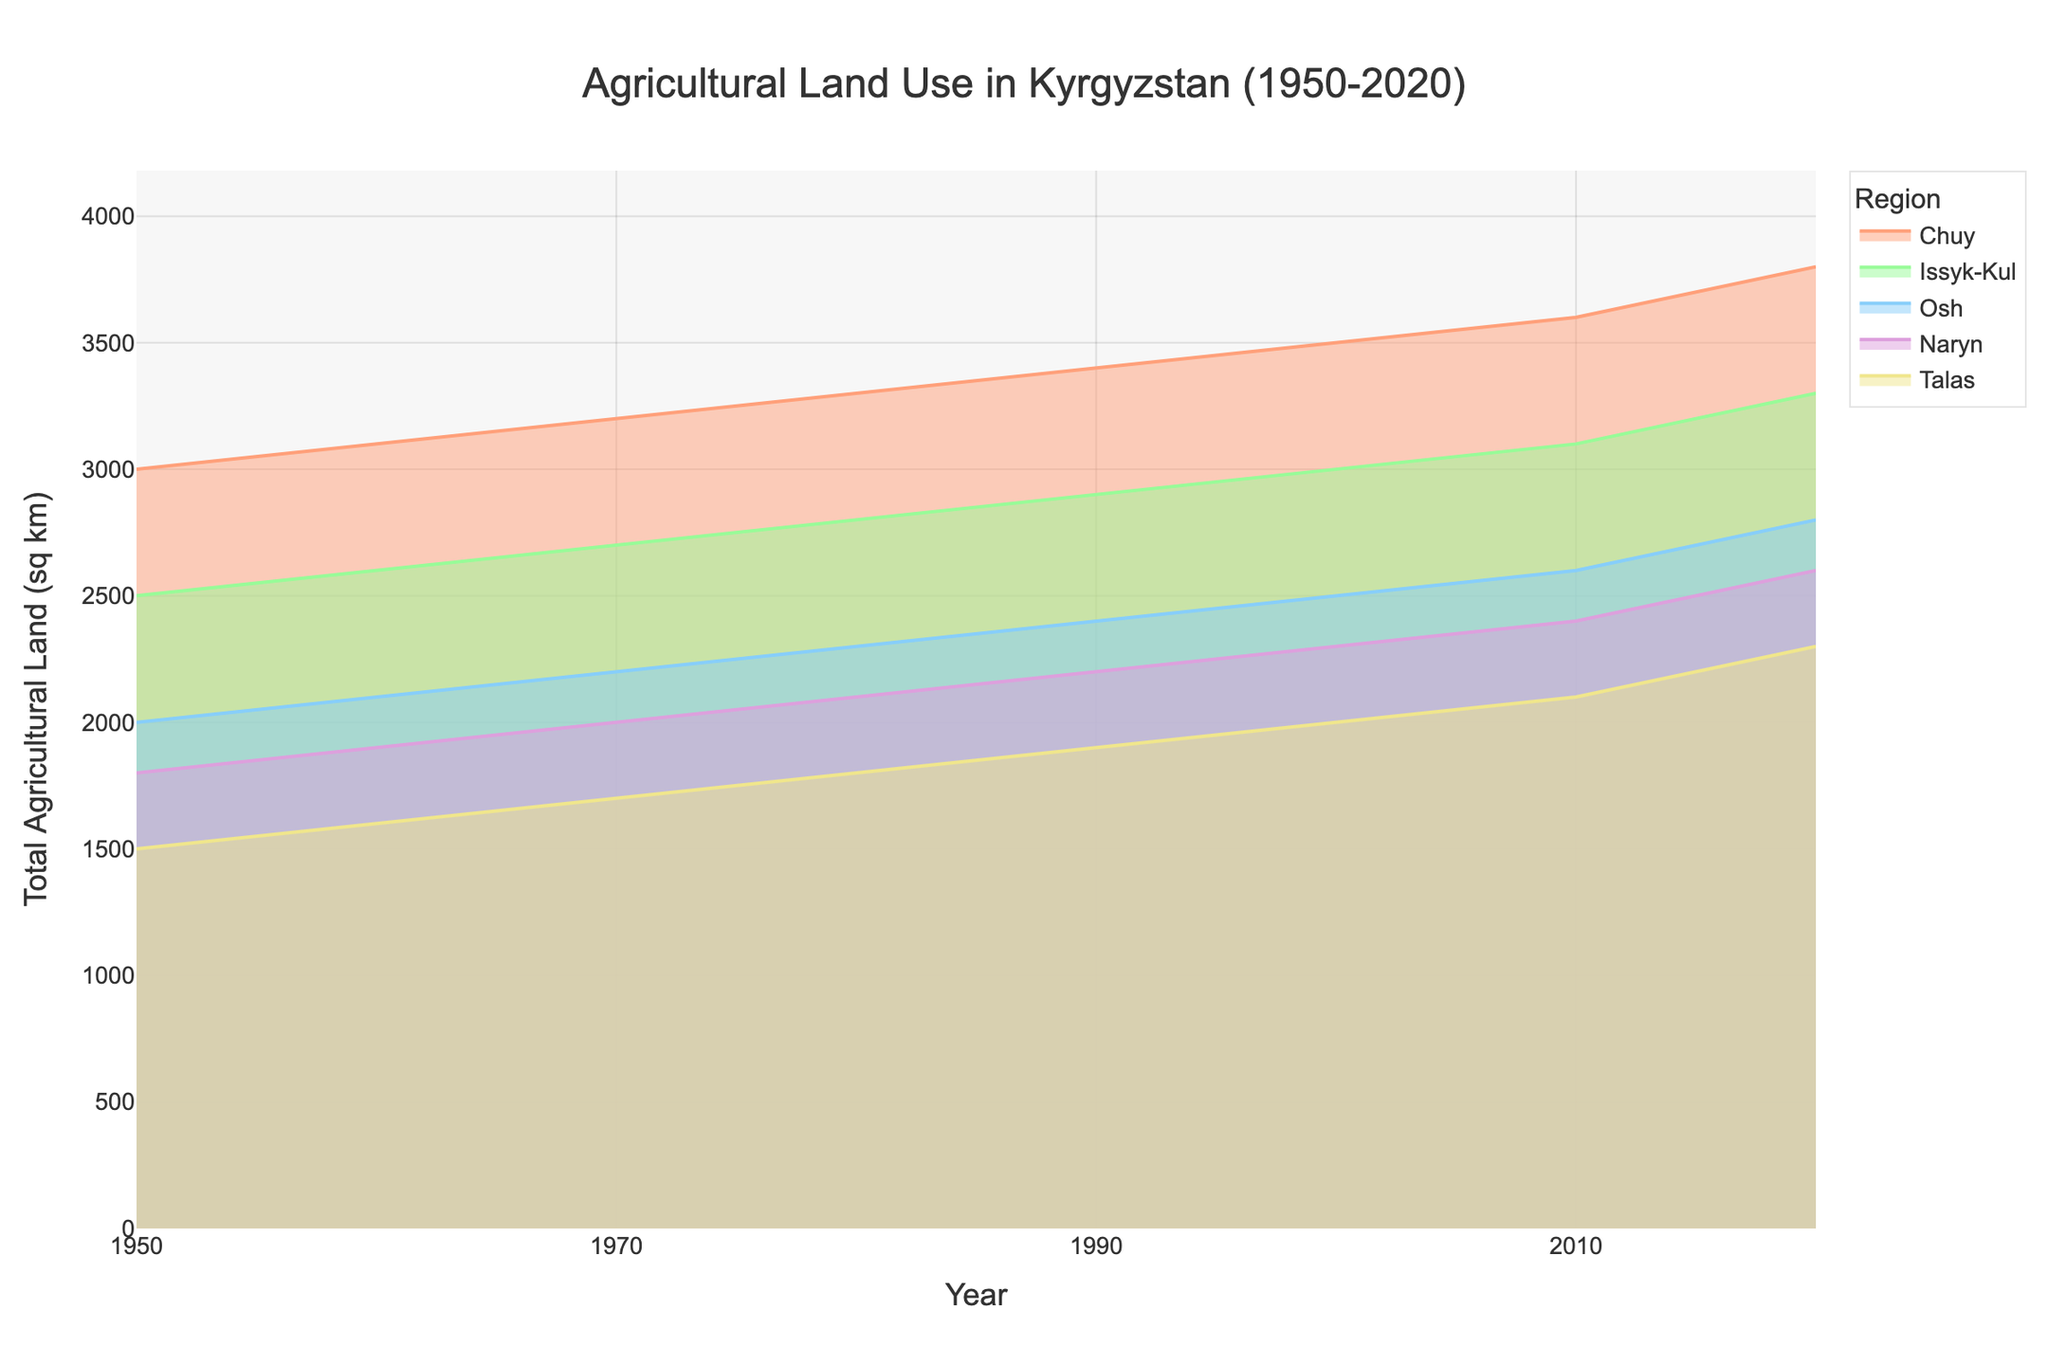What is the title of the figure? The title is usually placed at the top of the figure. In this case, the title is "Agricultural Land Use in Kyrgyzstan (1950-2020)"
Answer: Agricultural Land Use in Kyrgyzstan (1950-2020) What does the x-axis represent? The x-axis at the bottom of the figure represents the time period over which the data was collected. It shows the years from 1950 to 2020 in intervals of 20 years.
Answer: Year What does the y-axis represent? The y-axis on the left side of the figure represents the total agricultural land used in square kilometers across different regions of Kyrgyzstan.
Answer: Total Agricultural Land (sq km) How many regions are illustrated in the plot? The legend indicates the number of different colors used, each representing a distinct region. There are five regions represented: Chuy, Issyk-Kul, Osh, Naryn, and Talas.
Answer: 5 Which region had the largest increase in the total agricultural land from 1950 to 2020? To find the region with the largest increase, compare the starting point (1950) and ending point (2020) for each region. Chuy started at 3000 sq km and ended at 3800 sq km, showing the largest increase of 800 sq km.
Answer: Chuy What is the trend in the total agricultural land for Issyk-Kul between 1950 and 2020? Observe the line representing Issyk-Kul. It shows a continuous upward trend from 2500 sq km in 1950 to 3300 sq km in 2020, indicating consistent growth.
Answer: Increasing trend In which decade did Osh see the most substantial growth in agricultural land? Look for the steepest slope in Osh's line. The steepest increase appears between 1990 and 2010, where the land increased from 2400 sq km to 2600 sq km.
Answer: 1990-2010 Compare the total agricultural land of Talas and Naryn in 1950. Which one was higher? Examine the starting points on the y-axis for both Talas and Naryn in 1950. Talas had 1500 sq km, and Naryn had 1800 sq km, so Naryn was higher.
Answer: Naryn Combine the total agricultural land in 2020 for Chuy and Osh. What is the sum? Add the values for Chuy (3800 sq km) and Osh (2800 sq km) in 2020. The sum is 3800 + 2800 = 6600 sq km.
Answer: 6600 sq km What is the difference in the total agricultural land between Chuy and Issyk-Kul in 2020? Subtract the value for Issyk-Kul (3300 sq km) from Chuy (3800 sq km) in 2020. The difference is 3800 - 3300 = 500 sq km.
Answer: 500 sq km 